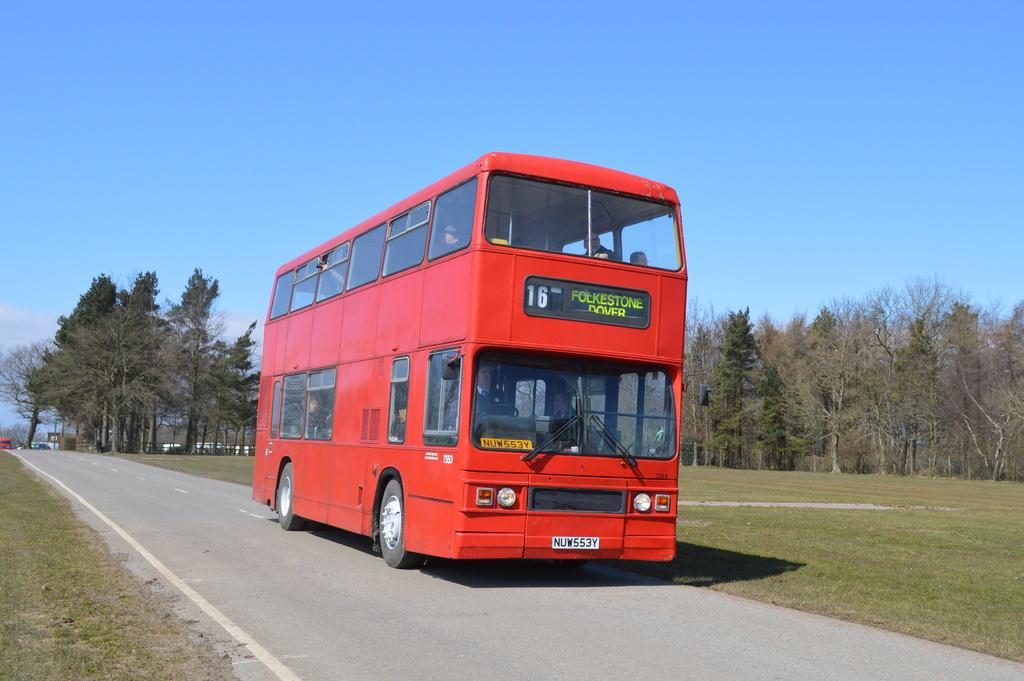What are the people in the image doing? The persons in the image are sitting inside a vehicle. What can be seen on the vehicle? The vehicle has text on it. Where is the vehicle located? The vehicle is parked on the ground. What can be seen in the background of the image? There is a group of trees and the sky visible in the background of the image. What type of tool is the carpenter using to taste the pail in the image? There is no carpenter, taste, or pail present in the image. 